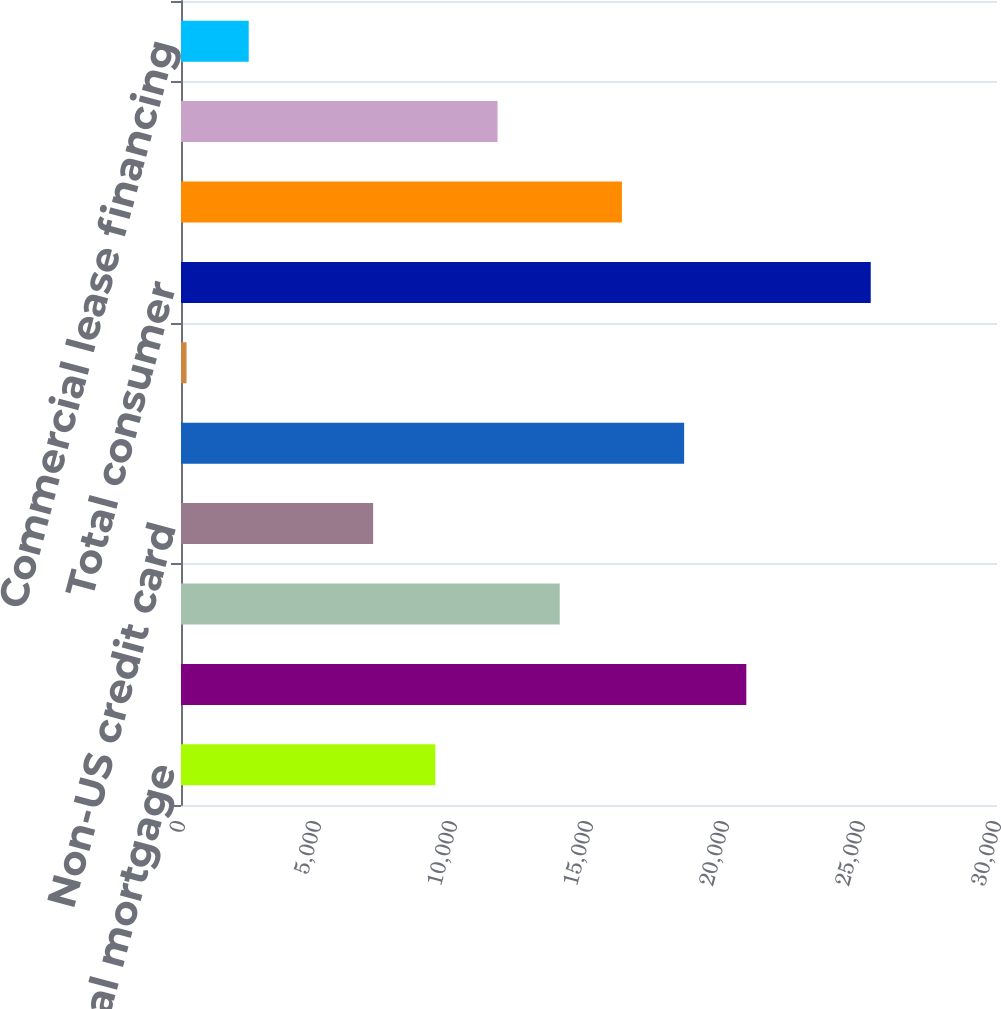<chart> <loc_0><loc_0><loc_500><loc_500><bar_chart><fcel>Residential mortgage<fcel>Home equity<fcel>US credit card<fcel>Non-US credit card<fcel>Direct/Indirect consumer<fcel>Other consumer<fcel>Total consumer<fcel>US commercial (1)<fcel>Commercial real estate<fcel>Commercial lease financing<nl><fcel>9350.2<fcel>20784.2<fcel>13923.8<fcel>7063.4<fcel>18497.4<fcel>203<fcel>25357.8<fcel>16210.6<fcel>11637<fcel>2489.8<nl></chart> 